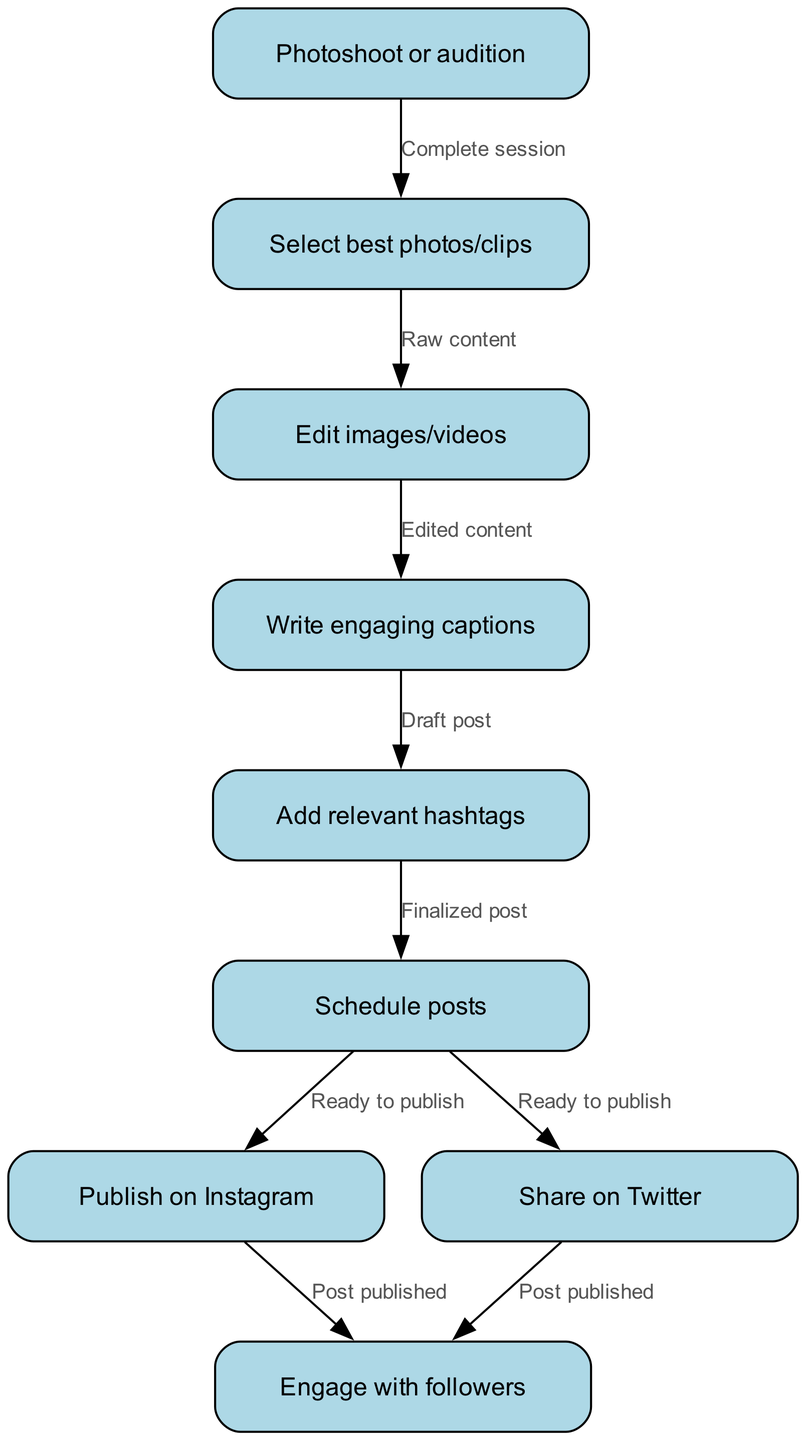What is the first step in the pipeline? The first step in the pipeline is represented by the node labeled "Photoshoot or audition." It is the starting point from which the content creation process begins.
Answer: Photoshoot or audition How many nodes are in the diagram? By counting the individual steps (nodes) in the diagram, there are a total of nine nodes listed, from "Photoshoot or audition" to "Engage with followers."
Answer: 9 What action follows editing the images or videos? After the "Edit images/videos" step, the action that follows is "Write engaging captions," as indicated by the edge connecting those nodes.
Answer: Write engaging captions Which nodes are connected to the "Schedule posts" node? The "Schedule posts" node connects to two nodes: "Publish on Instagram" and "Share on Twitter," as shown by the outgoing edges from that node.
Answer: Publish on Instagram, Share on Twitter What is the last step after engaging with followers? The "Engage with followers" node does not lead to any further action, making it the final step in this pipeline and the endpoint of the flowchart.
Answer: Engage with followers Which node receives content after selecting photos and clips? The node that receives content after "Select best photos/clips" is "Edit images/videos," which is where the selected content is processed further.
Answer: Edit images/videos How many edges are connecting the nodes? Counting all the connecting lines (edges) in the diagram shows there are a total of eight edges that depict the relationships between the nodes.
Answer: 8 What is the relationship between "Draft post" and "Add relevant hashtags"? The relationship is that after drafting a post with engaging captions, the next action is to "Add relevant hashtags," as indicated by the connecting edge between these two nodes.
Answer: Add relevant hashtags What do the two posts share after scheduling? The two scheduled posts share the same action of being "published," separately on Instagram and Twitter according to the diagram's edges.
Answer: Post published 